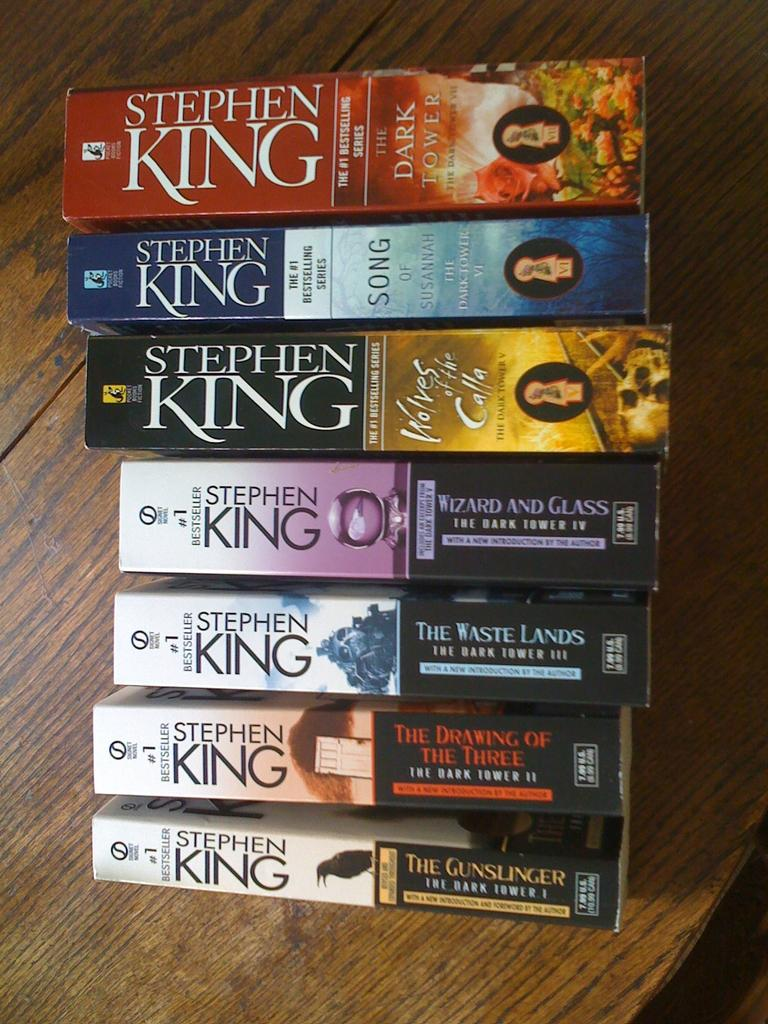<image>
Render a clear and concise summary of the photo. Seven Stephen King books on a table with the binding side up. 